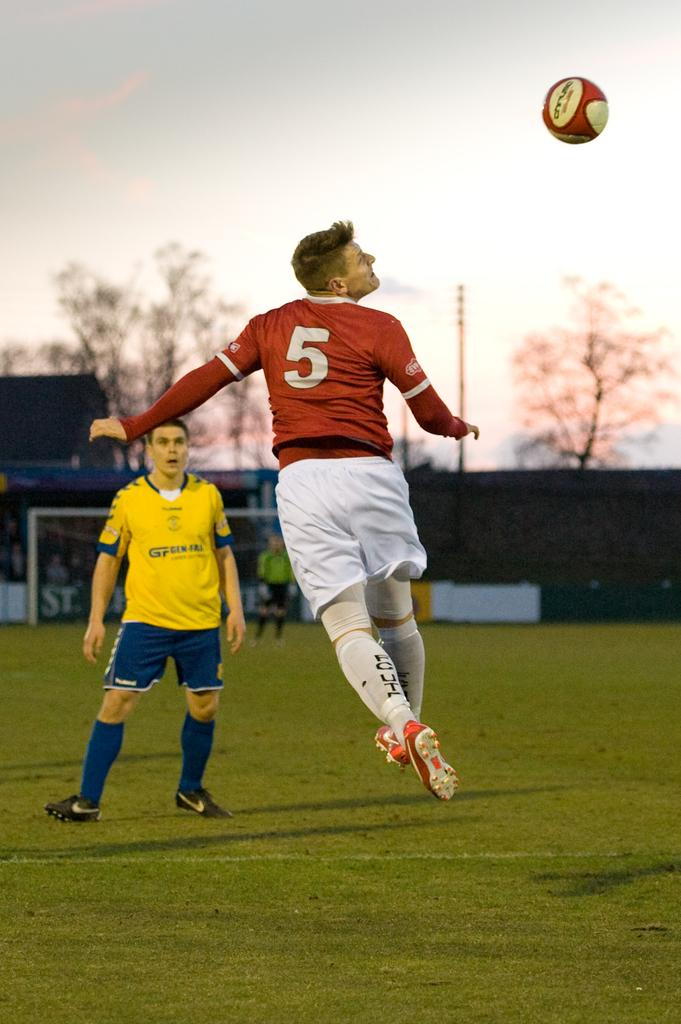<image>
Render a clear and concise summary of the photo. Two soccer players are trying to reach the ball and the player in a red jersey with a 5 on it is closest to the ball. 